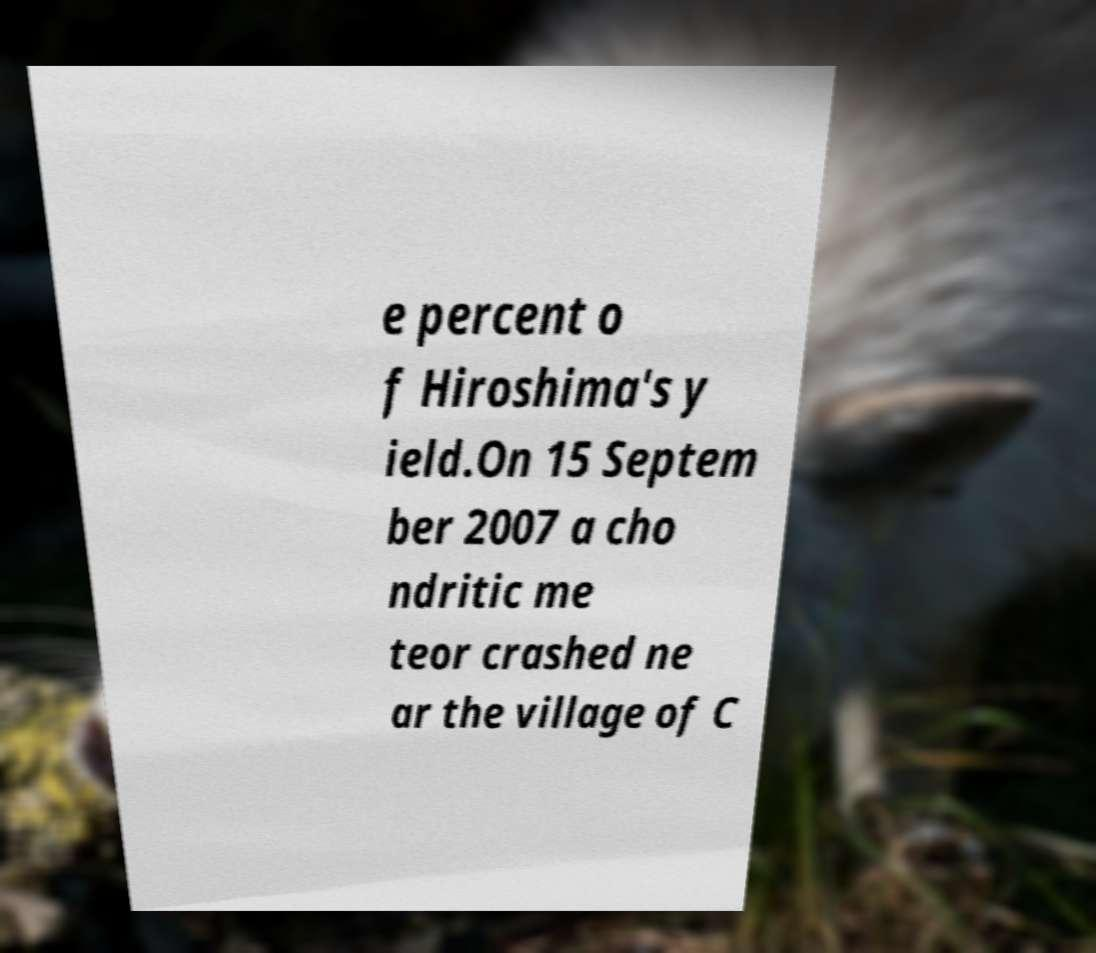Can you read and provide the text displayed in the image?This photo seems to have some interesting text. Can you extract and type it out for me? e percent o f Hiroshima's y ield.On 15 Septem ber 2007 a cho ndritic me teor crashed ne ar the village of C 